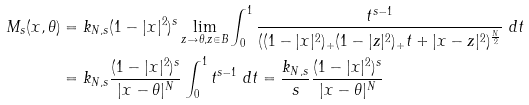<formula> <loc_0><loc_0><loc_500><loc_500>M _ { s } ( x , \theta ) & = k _ { N , s } ( 1 - | x | ^ { 2 } ) ^ { s } \lim _ { z \to \theta , z \in B } \int _ { 0 } ^ { 1 } \frac { t ^ { s - 1 } } { ( ( 1 - | x | ^ { 2 } ) _ { + } ( 1 - | z | ^ { 2 } ) _ { + } t + | x - z | ^ { 2 } ) ^ { \frac { N } { 2 } } } \ d t \\ & = k _ { N , s } \frac { ( 1 - | x | ^ { 2 } ) ^ { s } } { | x - \theta | ^ { N } } \int _ { 0 } ^ { 1 } t ^ { s - 1 } \ d t = \frac { k _ { N , s } } { s } \frac { ( 1 - | x | ^ { 2 } ) ^ { s } } { | x - \theta | ^ { N } }</formula> 